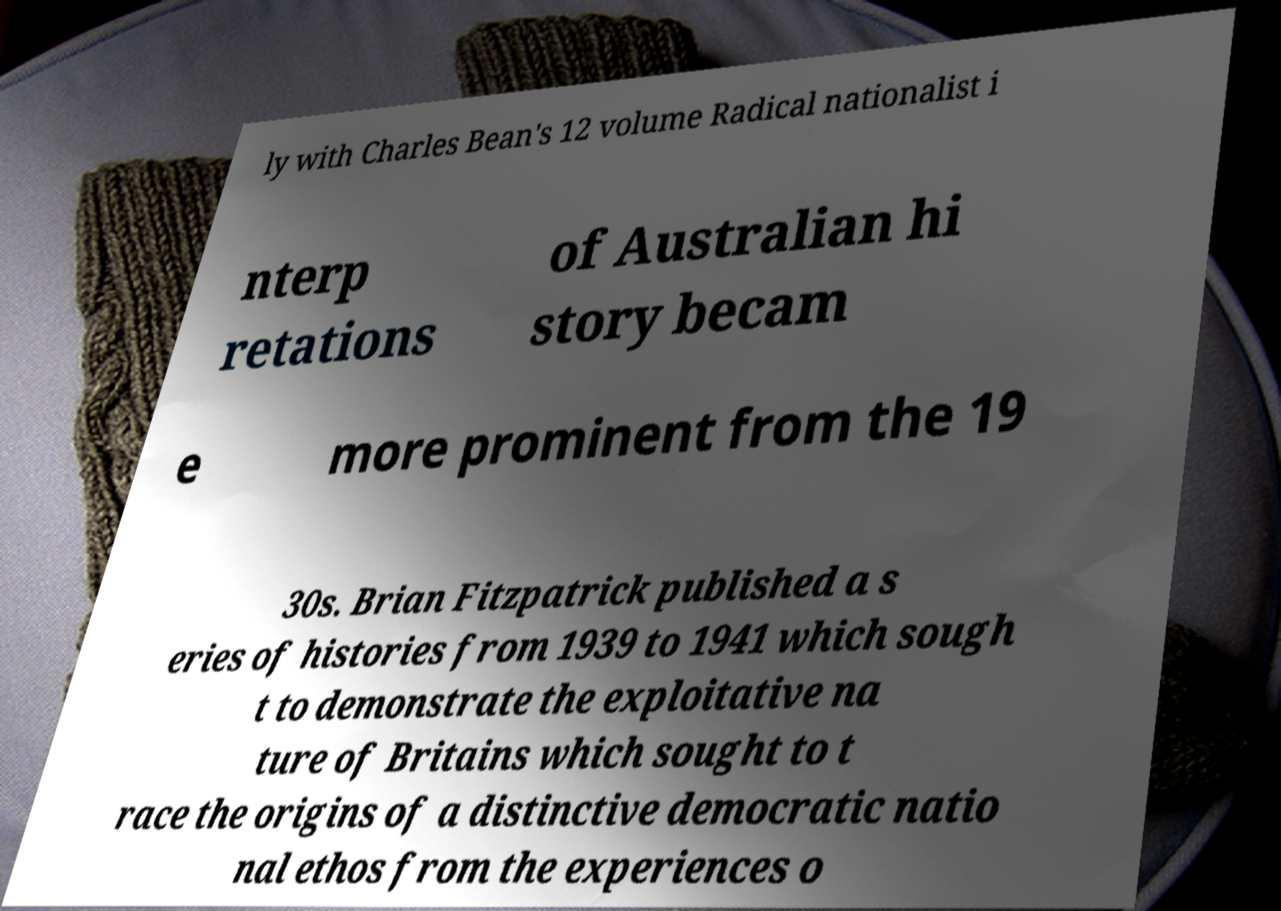I need the written content from this picture converted into text. Can you do that? ly with Charles Bean's 12 volume Radical nationalist i nterp retations of Australian hi story becam e more prominent from the 19 30s. Brian Fitzpatrick published a s eries of histories from 1939 to 1941 which sough t to demonstrate the exploitative na ture of Britains which sought to t race the origins of a distinctive democratic natio nal ethos from the experiences o 